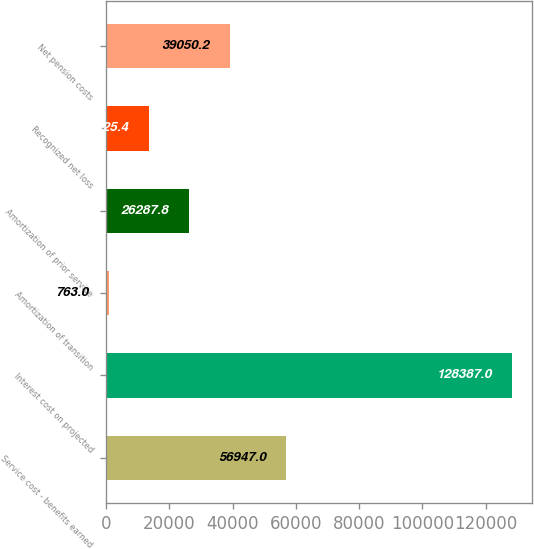<chart> <loc_0><loc_0><loc_500><loc_500><bar_chart><fcel>Service cost - benefits earned<fcel>Interest cost on projected<fcel>Amortization of transition<fcel>Amortization of prior service<fcel>Recognized net loss<fcel>Net pension costs<nl><fcel>56947<fcel>128387<fcel>763<fcel>26287.8<fcel>13525.4<fcel>39050.2<nl></chart> 